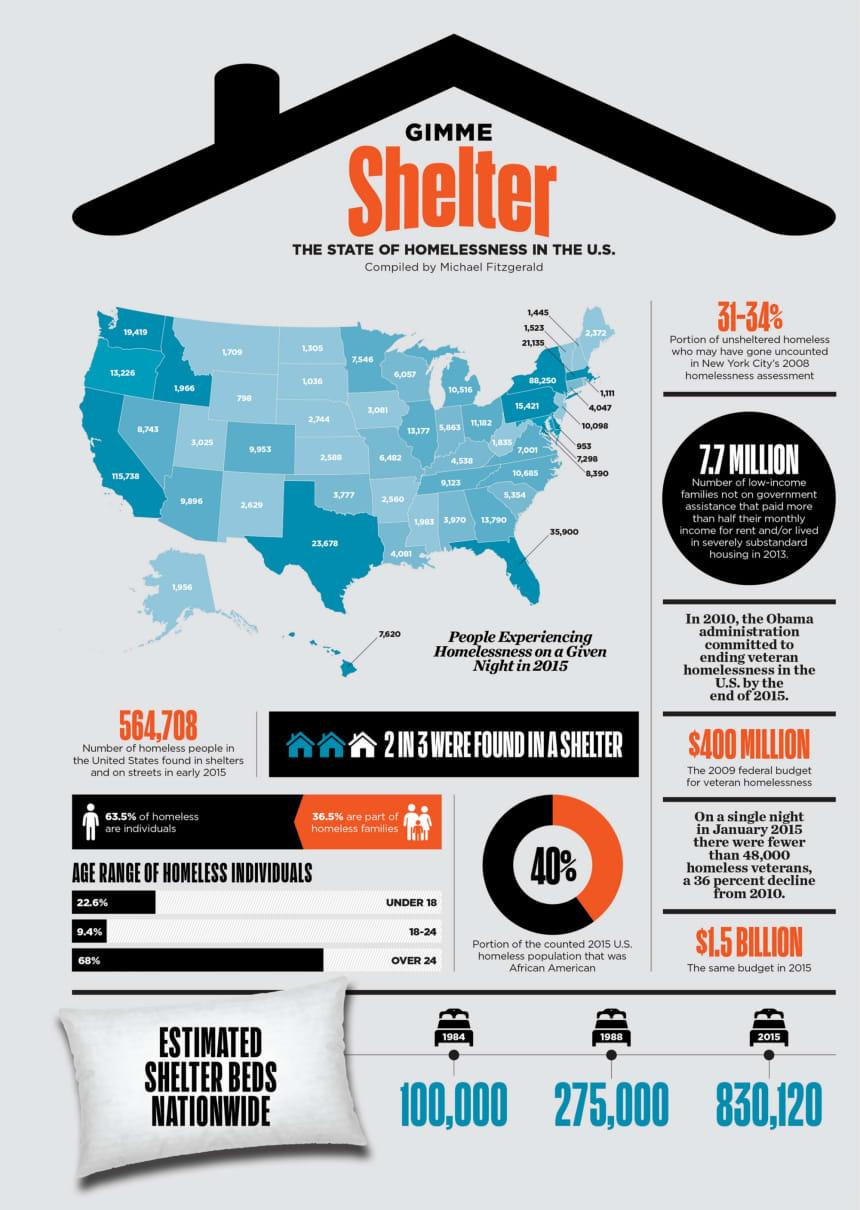Identify some key points in this picture. In 1984, it was estimated that there were approximately 100,000 shelter beds available for homeless individuals nationwide. The estimated number of shelter beds for homeless individuals in the United States in 2015 was approximately 830,120. The African American community constituted 40% of the counted homeless population in the United States in 2015. According to recent statistics, a significant percentage of homeless individuals in the United States are over the age of 24. Specifically, 68% of homeless individuals fall into this age category. According to data in the United States, individuals in the age group of 18-24 have accounted for 9.4% of the homeless population. 